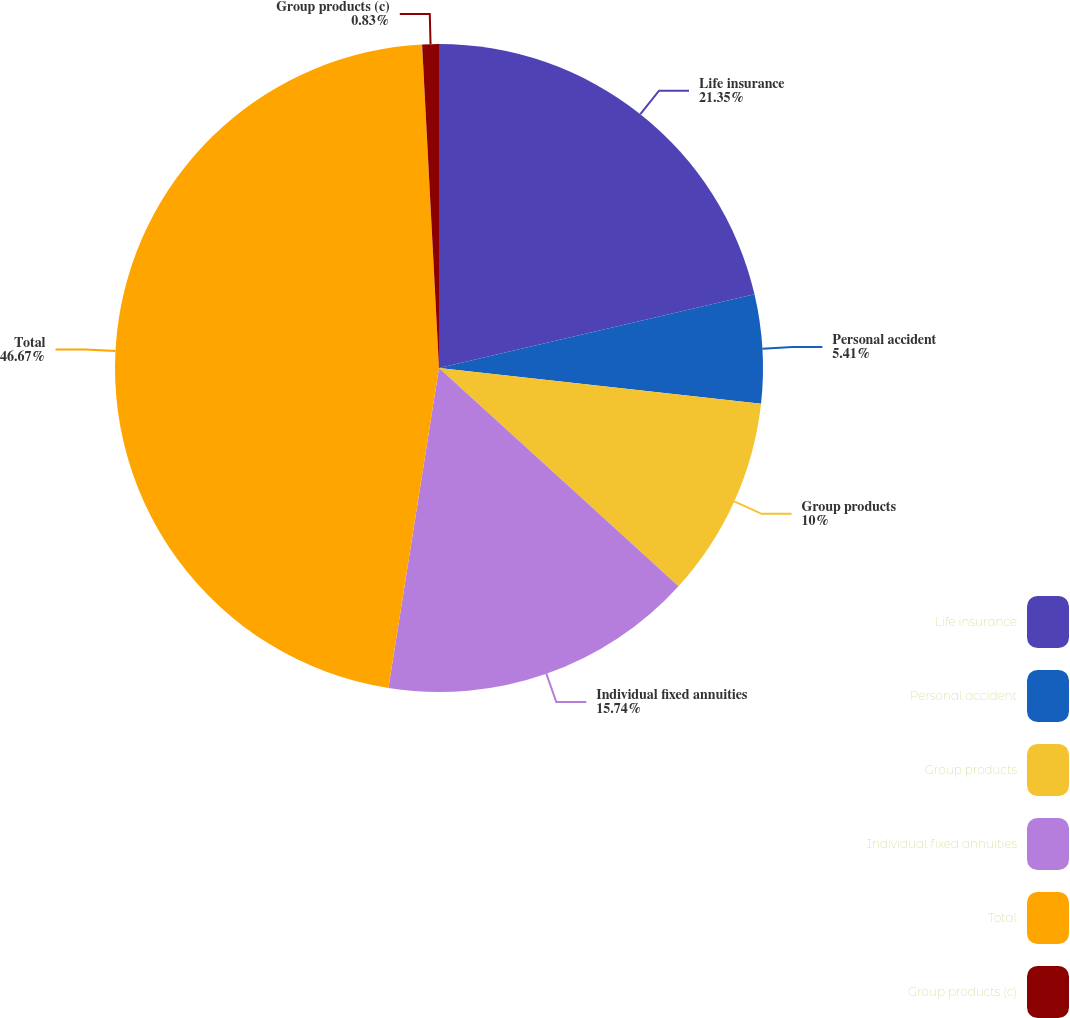<chart> <loc_0><loc_0><loc_500><loc_500><pie_chart><fcel>Life insurance<fcel>Personal accident<fcel>Group products<fcel>Individual fixed annuities<fcel>Total<fcel>Group products (c)<nl><fcel>21.35%<fcel>5.41%<fcel>10.0%<fcel>15.74%<fcel>46.68%<fcel>0.83%<nl></chart> 